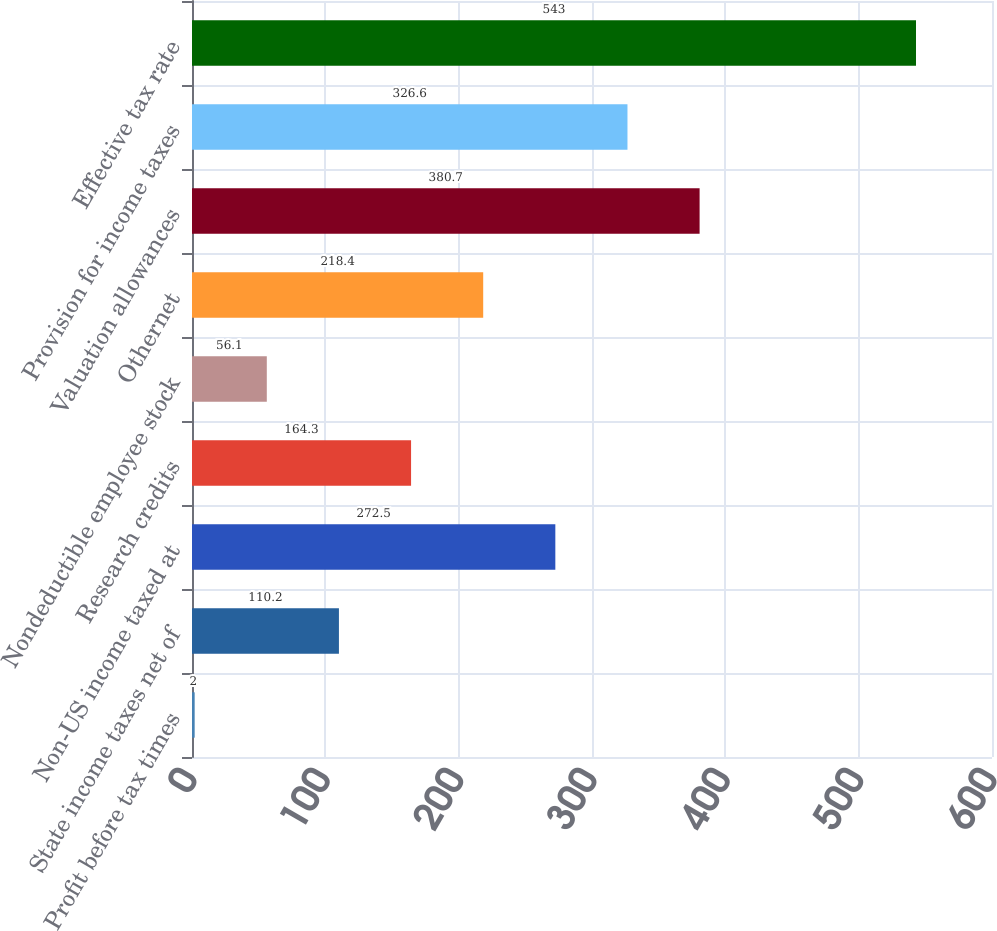Convert chart to OTSL. <chart><loc_0><loc_0><loc_500><loc_500><bar_chart><fcel>Profit before tax times<fcel>State income taxes net of<fcel>Non-US income taxed at<fcel>Research credits<fcel>Nondeductible employee stock<fcel>Othernet<fcel>Valuation allowances<fcel>Provision for income taxes<fcel>Effective tax rate<nl><fcel>2<fcel>110.2<fcel>272.5<fcel>164.3<fcel>56.1<fcel>218.4<fcel>380.7<fcel>326.6<fcel>543<nl></chart> 